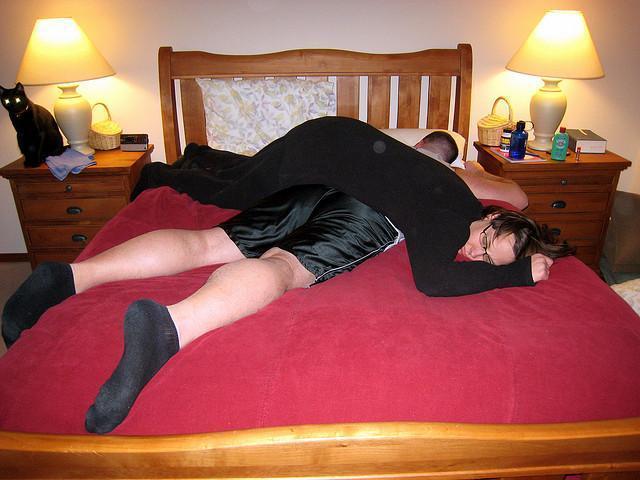How many people are in the picture?
Give a very brief answer. 2. 